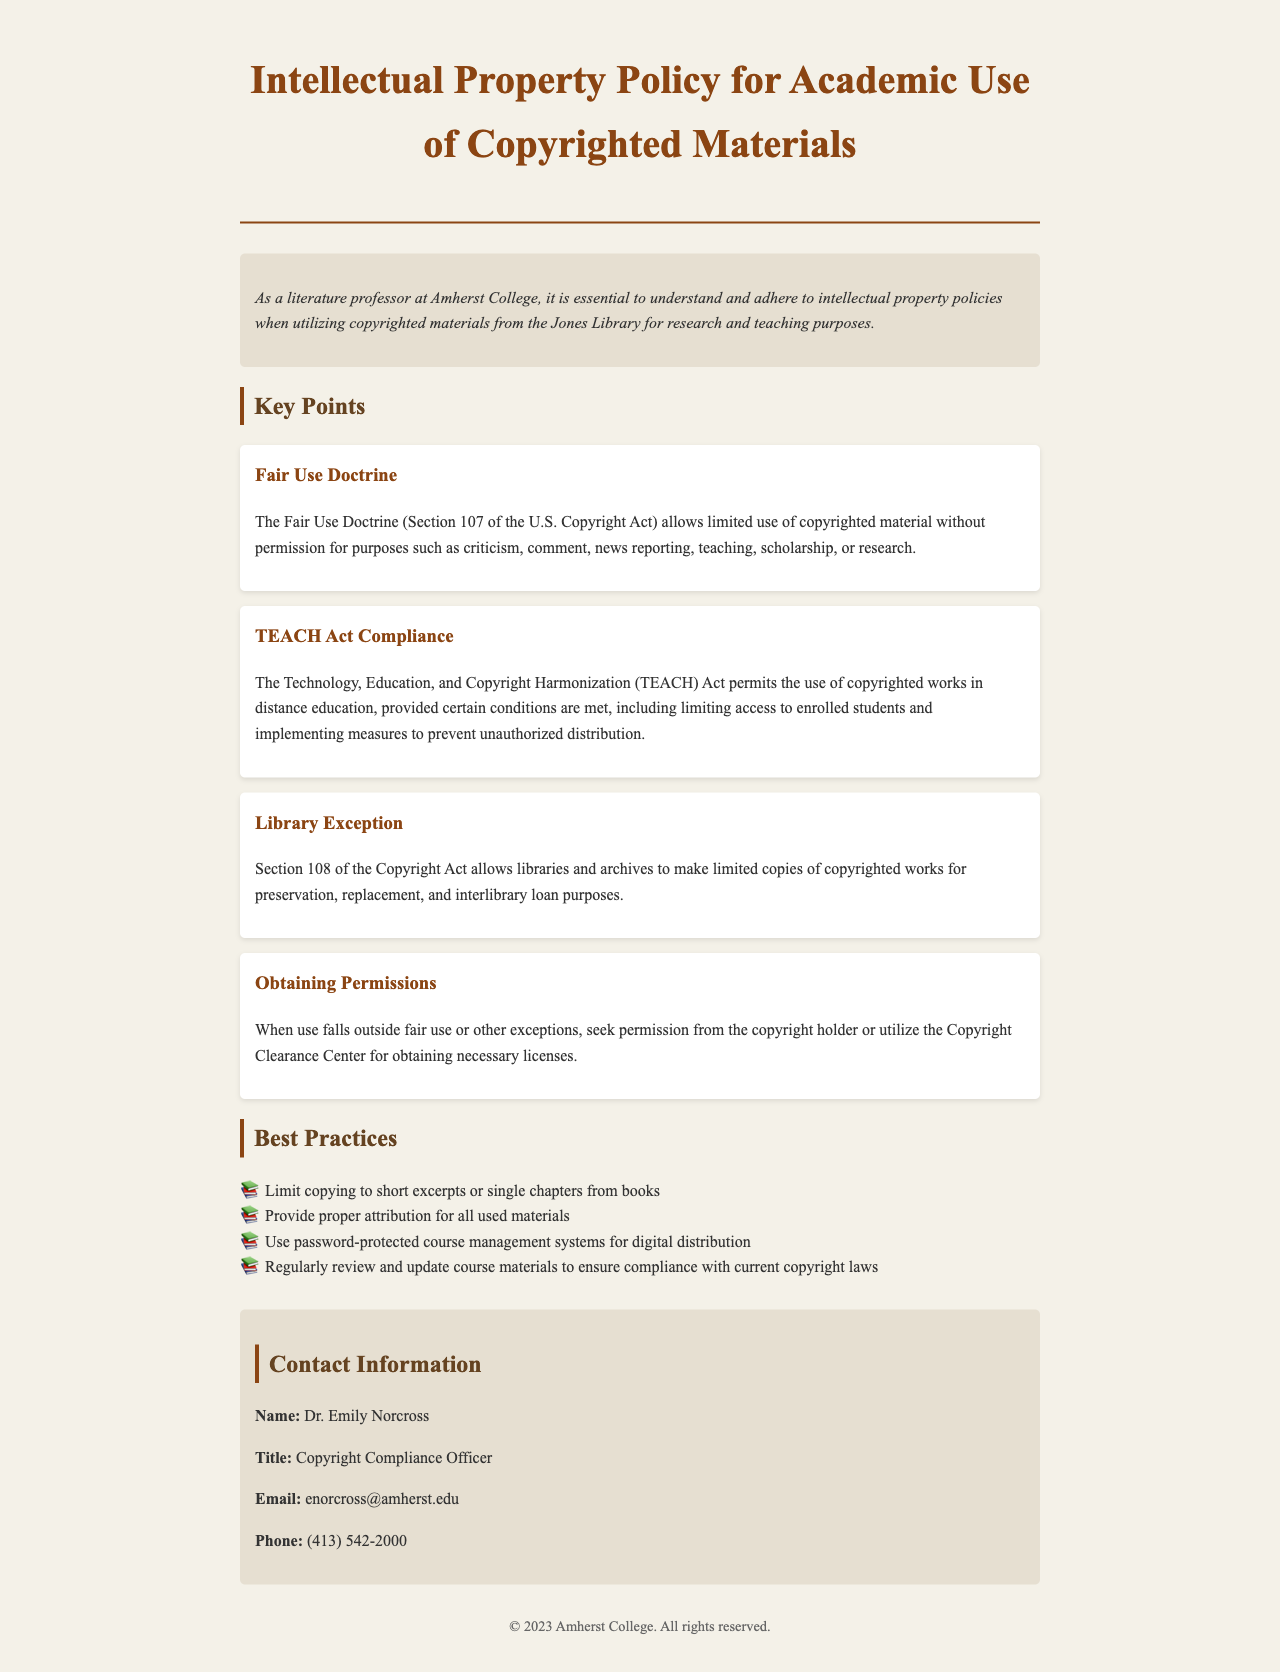What is the title of the policy document? The title is stated clearly at the beginning of the document, indicating its focus on intellectual property in academic contexts.
Answer: Intellectual Property Policy for Academic Use of Copyrighted Materials Who is the Copyright Compliance Officer? The document provides a specific individual responsible for copyright compliance, indicating their role in academic settings.
Answer: Dr. Emily Norcross What is the Fair Use Doctrine associated with? The document mentions the Fair Use Doctrine in the context of U.S. copyright law and its allowances.
Answer: Section 107 of the U.S. Copyright Act What does the TEACH Act permit? The document explains that the TEACH Act governs the use of copyrighted materials in educational environments, detailing specific conditions that must be met.
Answer: Use of copyrighted works in distance education What should be done when use falls outside of fair use? The document discusses obtaining permissions as a necessary action when certain exceptions are not applicable, providing guidance in such scenarios.
Answer: Seek permission from the copyright holder What is a best practice for copying materials? The document lists a guideline aimed at ensuring compliance with copyright policies, emphasizing a cautious approach to material usage.
Answer: Limit copying to short excerpts or single chapters from books Which section of the Copyright Act allows libraries to make copies? The document identifies a particular section that grants libraries specific rights concerning copyrighted materials.
Answer: Section 108 What is one measure to prevent unauthorized distribution? The document mentions specific practices aimed at securing educational materials, highlighting the importance of access control.
Answer: Use password-protected course management systems 